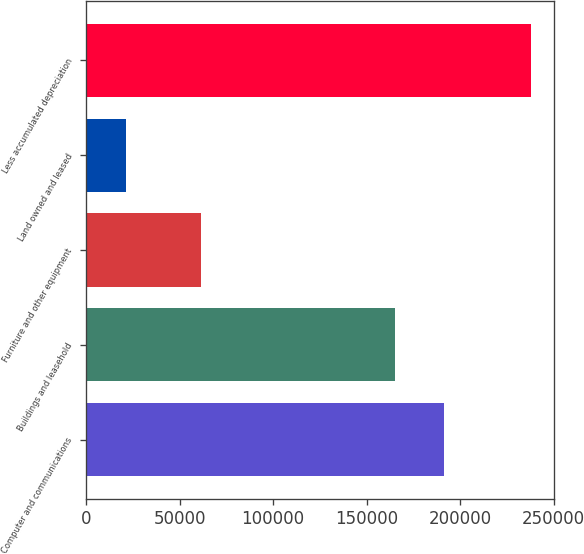<chart> <loc_0><loc_0><loc_500><loc_500><bar_chart><fcel>Computer and communications<fcel>Buildings and leasehold<fcel>Furniture and other equipment<fcel>Land owned and leased<fcel>Less accumulated depreciation<nl><fcel>191118<fcel>165127<fcel>61479<fcel>21503<fcel>238133<nl></chart> 